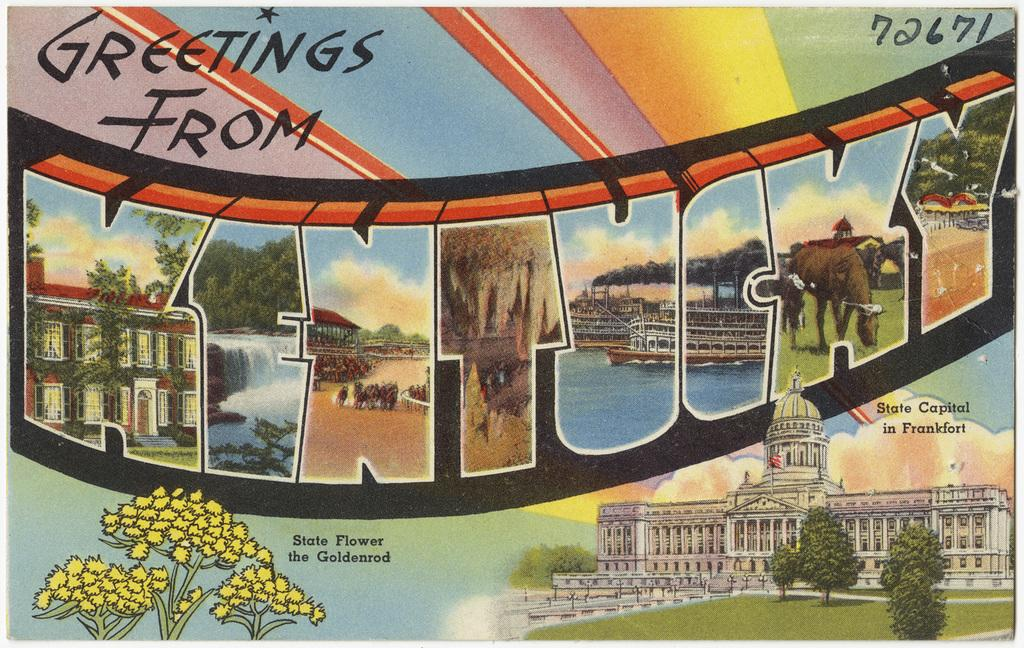<image>
Provide a brief description of the given image. a postcard that says 'greetings from kentucky' on it 